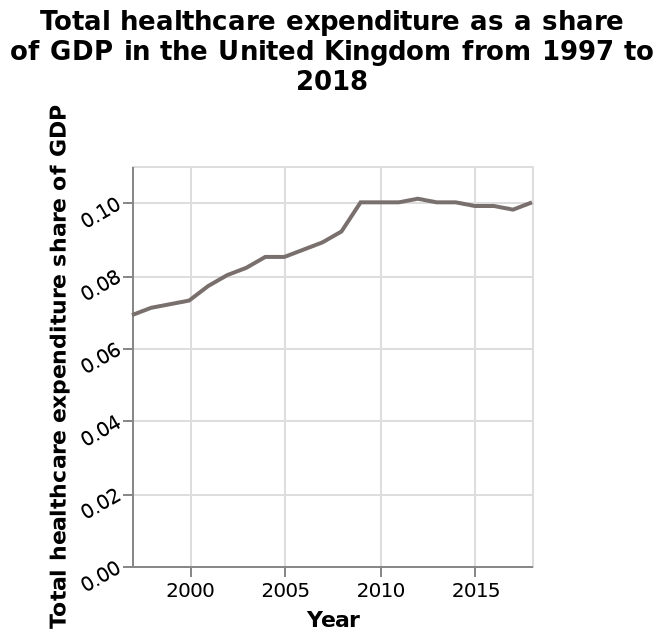<image>
What happens to the total health care expenditure share of GDP past 2015? The total health care expenditure share of GDP decreases slightly past 2015. What is the minimum value on the x-axis? The minimum value on the x-axis is 2000. What is the title of the line plot? The title of the line plot is "Total healthcare expenditure as a share of GDP in the United Kingdom from 1997 to 2018." How does the total health care expenditure share of GDP change towards the end of the graph? The total health care expenditure share of GDP begins to rise again towards the end of the graph. 